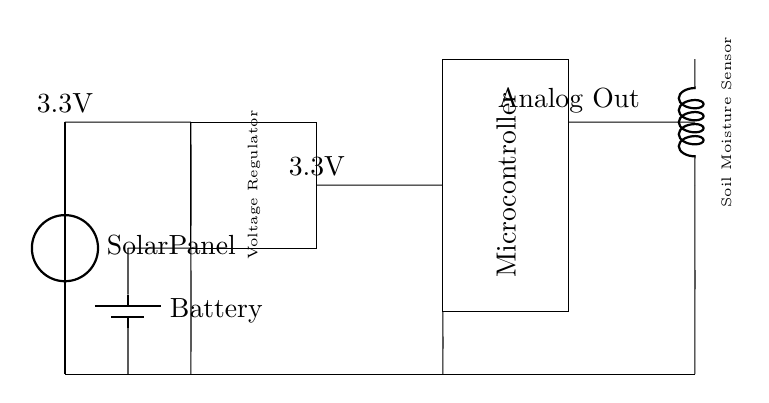What type of panel is used in this circuit? The circuit contains a solar panel, as indicated by the label next to the voltage source symbol. This panel is responsible for converting solar energy into electrical energy for the circuit.
Answer: Solar Panel What is the output voltage of the solar panel? The voltage symbol next to the solar panel states that it provides 3.3V, which is the designated output voltage for the panel.
Answer: 3.3V What component is responsible for regulating the voltage? The circuit includes a voltage regulator, indicated by the rectangular block labeled "Voltage Regulator." This component ensures that the output voltage remains stable at 3.3V regardless of variations in the input voltage from the solar panel.
Answer: Voltage Regulator What component is connected to the soil moisture sensor? The soil moisture sensor is directly connected to the microcontroller, as visualized by the line connecting these two components. This connection allows the microcontroller to read the data provided by the soil moisture sensor.
Answer: Microcontroller How many components are connected to ground? The circuit shows four different connections to ground: the solar panel, the voltage regulator, the microcontroller, and the soil moisture sensor, which indicates that they all share a common ground reference.
Answer: Four What is the power source for the circuit? A battery is depicted in the circuit as the additional power source. The battery connects to the solar panel and voltage regulator, allowing the circuit to function even in low light conditions.
Answer: Battery What type of sensor is included in this circuit? The circuit diagram shows a soil moisture sensor, explicitly mentioned in the label near the cute inductor symbol. This sensor measures the moisture level in the soil for monitoring purposes.
Answer: Soil Moisture Sensor 